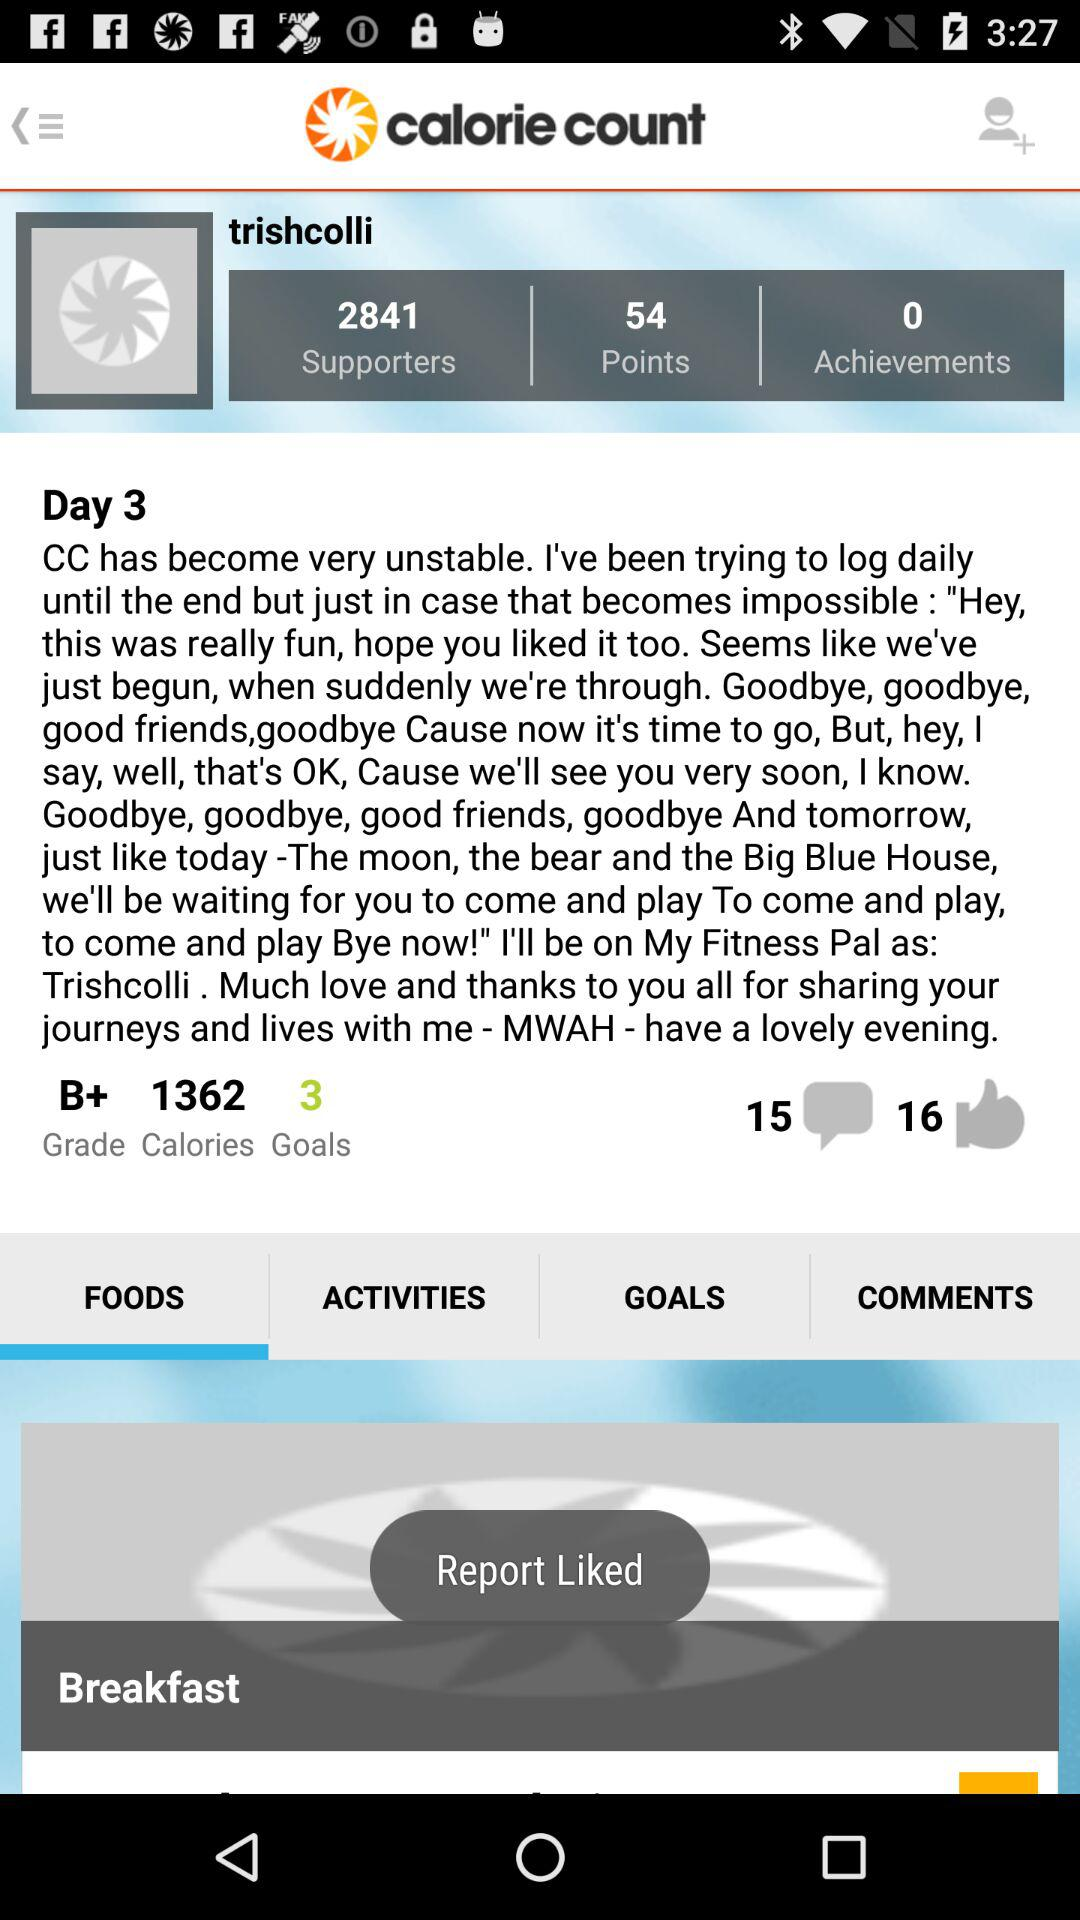How many goals does the user have?
Answer the question using a single word or phrase. 3 